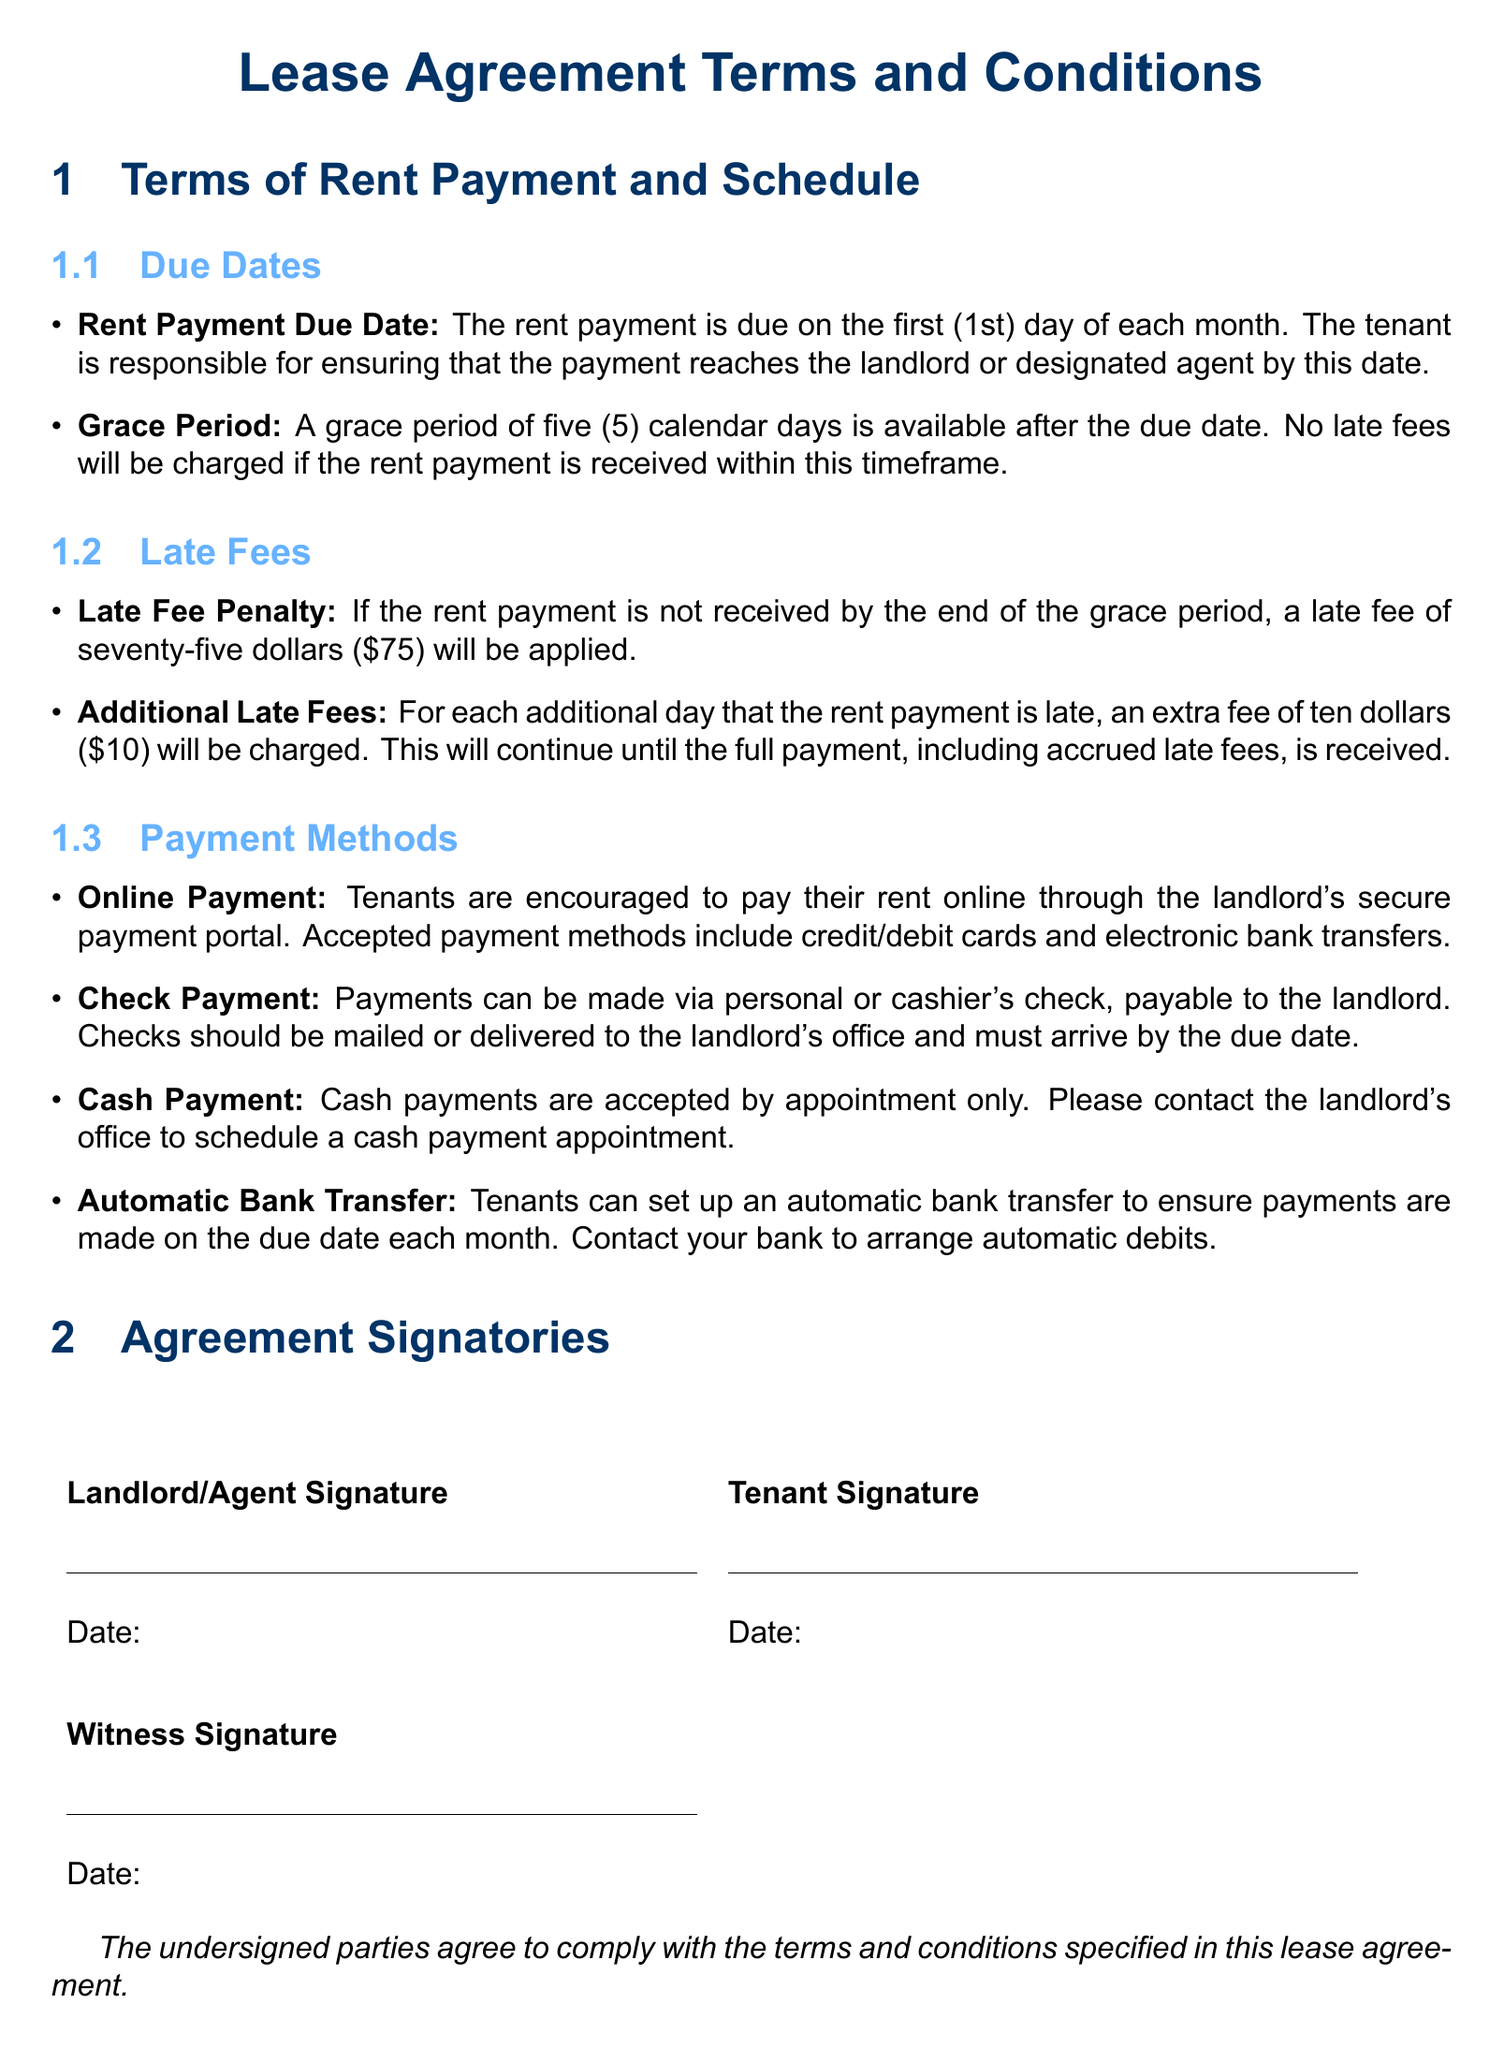What is the rent payment due date? The rent payment is due on the first (1st) day of each month.
Answer: first (1st) day of each month What is the grace period for rent payment? A grace period of five (5) calendar days is available after the due date.
Answer: five (5) calendar days What is the late fee penalty after the grace period? If the rent payment is not received by the end of the grace period, a late fee of seventy-five dollars will be applied.
Answer: seventy-five dollars What is the additional late fee for each day the rent is late? An extra fee of ten dollars will be charged for each additional day that the rent payment is late.
Answer: ten dollars What payment method is encouraged for tenants? Tenants are encouraged to pay their rent online through the landlord's secure payment portal.
Answer: online payment How can tenants make cash payments? Cash payments are accepted by appointment only.
Answer: by appointment only How should checks be made out? Payments can be made via personal or cashier's check, payable to the landlord.
Answer: payable to the landlord What should tenants do to set up automatic rent payment? Tenants can set up an automatic bank transfer to ensure payments are made on the due date each month.
Answer: set up an automatic bank transfer 